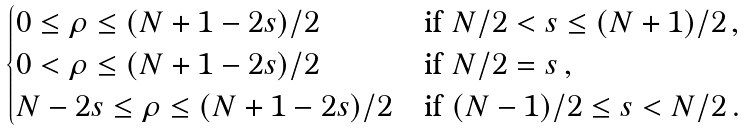<formula> <loc_0><loc_0><loc_500><loc_500>\begin{cases} 0 \leq \rho \leq ( N + 1 - 2 s ) / 2 & \text {if} \ N / 2 < s \leq ( N + 1 ) / 2 \, , \\ 0 < \rho \leq ( N + 1 - 2 s ) / 2 & \text {if} \ N / 2 = s \, , \\ N - 2 s \leq \rho \leq ( N + 1 - 2 s ) / 2 & \text {if} \ ( N - 1 ) / 2 \leq s < N / 2 \, . \end{cases}</formula> 